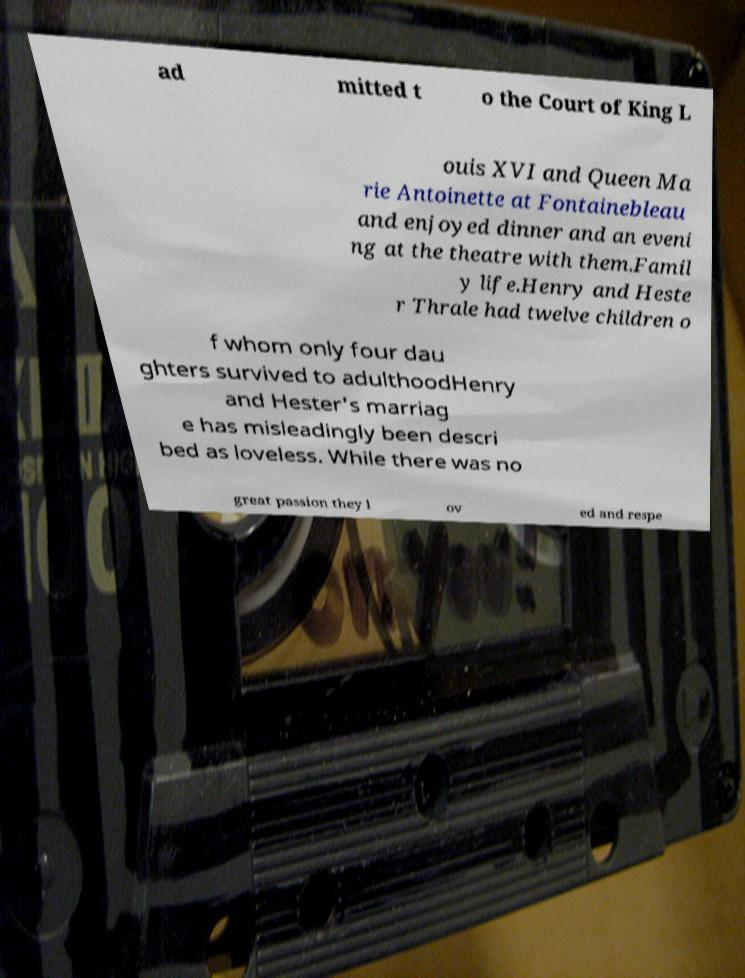Could you extract and type out the text from this image? ad mitted t o the Court of King L ouis XVI and Queen Ma rie Antoinette at Fontainebleau and enjoyed dinner and an eveni ng at the theatre with them.Famil y life.Henry and Heste r Thrale had twelve children o f whom only four dau ghters survived to adulthoodHenry and Hester's marriag e has misleadingly been descri bed as loveless. While there was no great passion they l ov ed and respe 